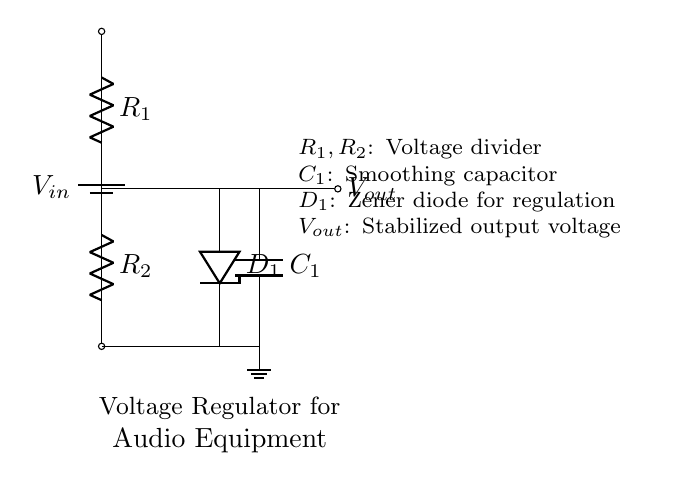What type of circuit is illustrated? The circuit illustrated is a voltage divider circuit because it is using resistors to divide voltage, specifically R1 and R2 are configured to achieve this purpose.
Answer: Voltage Divider What component is used for voltage regulation? The Zener diode labeled D1 is used for voltage regulation; it ensures that the output voltage remains stable and does not exceed a predetermined value.
Answer: Zener Diode What is the function of the capacitor C1? The capacitor C1 is used for smoothing; it helps to smooth out the fluctuations in the output voltage after regulation, providing a more stable voltage supply.
Answer: Smoothing What are the values across R1 and R2 in this configuration? The values across R1 and R2 add up to the input voltage, V_in, and are divided according to their resistance values through Ohm's Law, leading to the output voltage, V_out, being a fraction of V_in.
Answer: V_in and V_out What is represented by V_out in this circuit? V_out represents the stabilized output voltage provided to sensitive audio equipment, which must remain constant despite variations in the input voltage or load conditions.
Answer: Stabilized Output Voltage How does the voltage divider affect the input voltage? The voltage divider reduces the input voltage according to the ratio of the resistances R1 and R2, thereby producing a lower output voltage suitable for sensitive equipment.
Answer: Reduces Input Voltage What is the purpose of the connection to ground in this circuit? The ground connection provides a reference point for the voltage levels in the circuit, completing the circuit and ensuring that the voltage measurements (output) are relative to a common return path.
Answer: Reference Point 